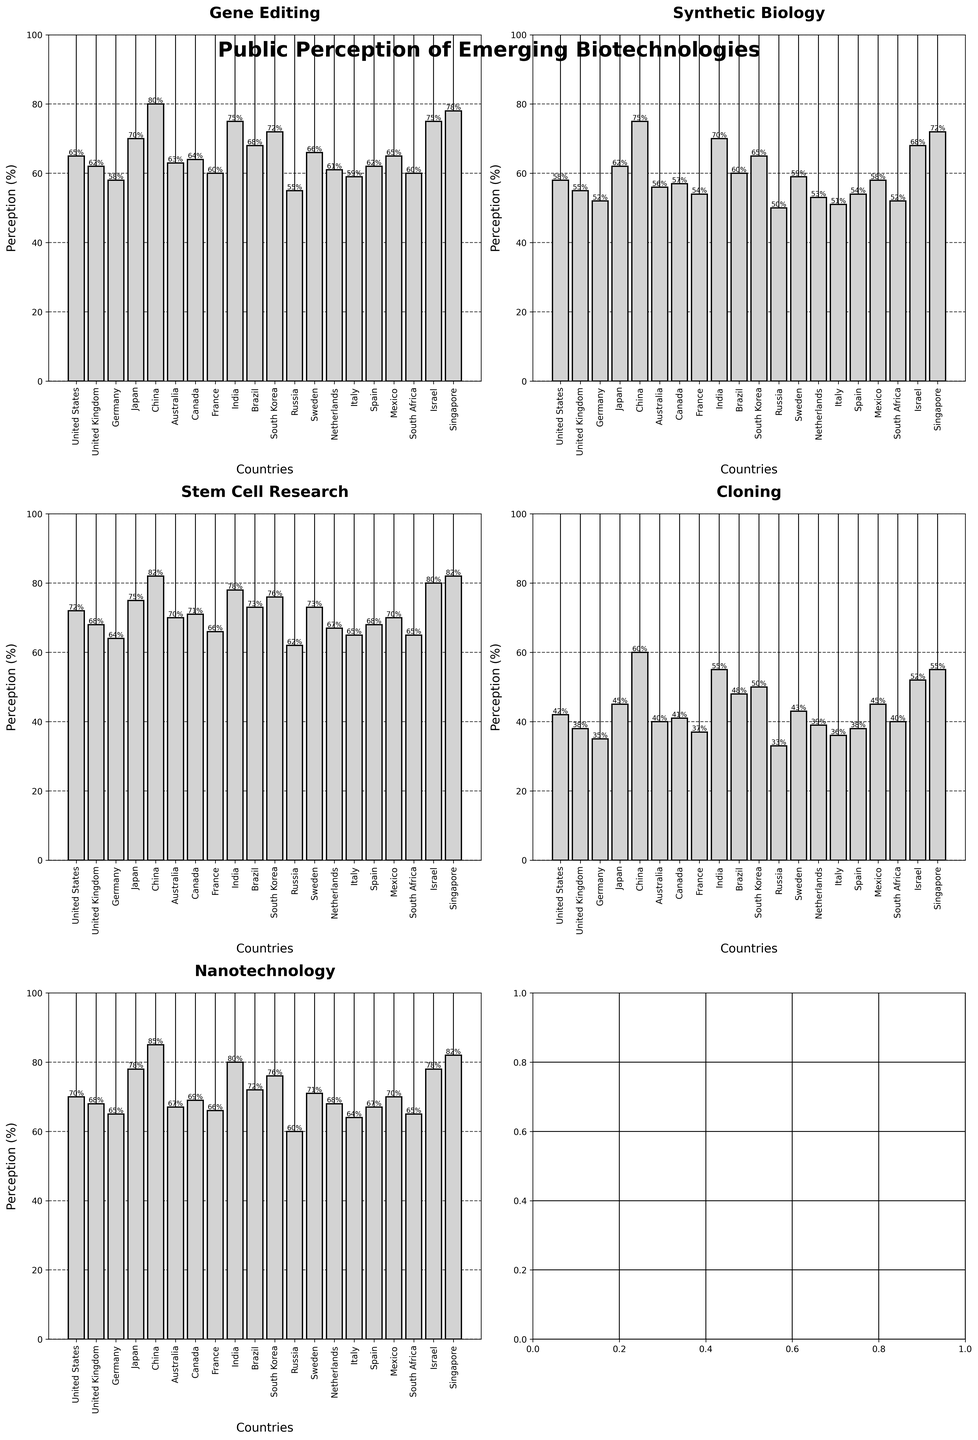Which country has the highest public perception of Gene Editing? To find the highest perception, look at the bars for Gene Editing and compare their heights. China has the tallest bar in the Gene Editing subplot.
Answer: China Which two countries have the closest levels of perception for Stem Cell Research? For Stem Cell Research, compare the heights of the bars. United States and Sweden both have perceptions of 73%.
Answer: United States and Sweden What is the average perception of Nanotechnology across all countries? Sum all the values for Nanotechnology and divide by the number of countries. (70+68+65+78+85+67+69+66+80+72+76+60+71+68+64+67+70+65+78+82)/20 = 70.35%
Answer: 70.35% Which technology has the highest perception in Japan? Observe the heights of the bars for each technology in the Japan subplot. Nanotechnology has the highest perception at 78%.
Answer: Nanotechnology How much higher is the perception of Cloning in India compared to Germany? Subtract the perception of Cloning in Germany from that in India. 55% (India) - 35% (Germany) = 20%
Answer: 20% Which three countries show the lowest public perception for Synthetic Biology? Identify the shortest bars in the Synthetic Biology subplot. Russia (50%), Germany (52%), South Africa (52%).
Answer: Russia, Germany, South Africa What is the median value for Gene Editing perceptions across all countries? Order the values and find the median: 55, 58, 59, 60, 60, 62, 62, 63, 64, 65, 65, 66, 68, 70, 72, 75, 75, 78, 80. The median value, being the middle one in the ordered list, is 65.
Answer: 65 Which country has the smallest difference in perception between Nanotechnology and Synthetic Biology? Calculate the difference for each country and find the smallest: Russia has the smallest difference with perceptions of 60% (Nanotechnology) and 50% (Synthetic Biology), difference is 10%.
Answer: Russia For all technologies, which country has the most balanced public perception, i.e., smallest range in perception values? Calculate the range for each country by subtracting the lowest perception value from the highest. Canada has perceptions of 64%, 57%, 71%, 41%, 69%; range = 71 - 41 = 30%.
Answer: Canada What is the total perception percentage for Gene Editing across the top 5 countries? Sum the values for Gene Editing for the top 5 countries by perception: China (80) + Singapore (78) + India (75) + Israel (75) + South Korea (72) = 380
Answer: 380 